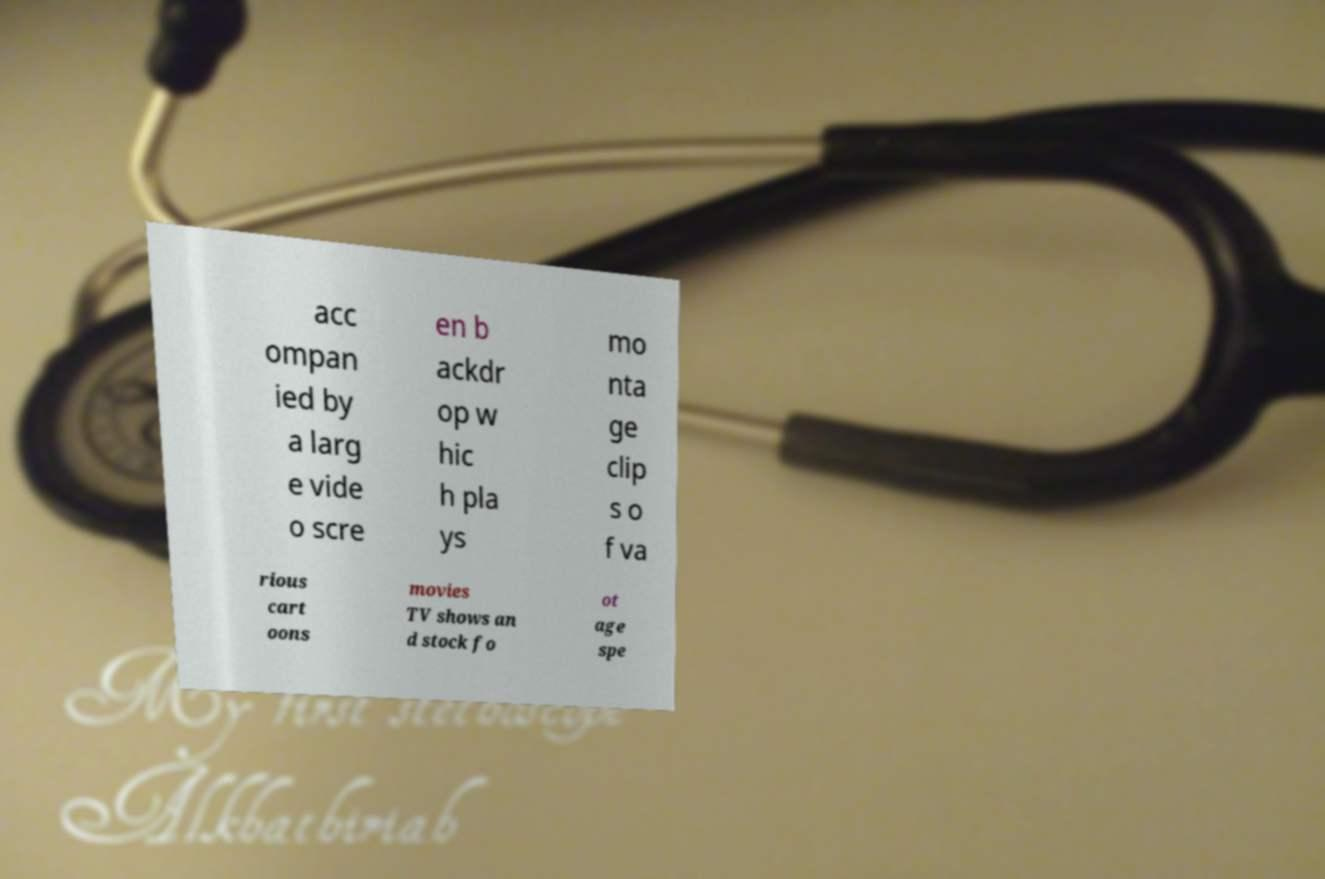Please read and relay the text visible in this image. What does it say? acc ompan ied by a larg e vide o scre en b ackdr op w hic h pla ys mo nta ge clip s o f va rious cart oons movies TV shows an d stock fo ot age spe 